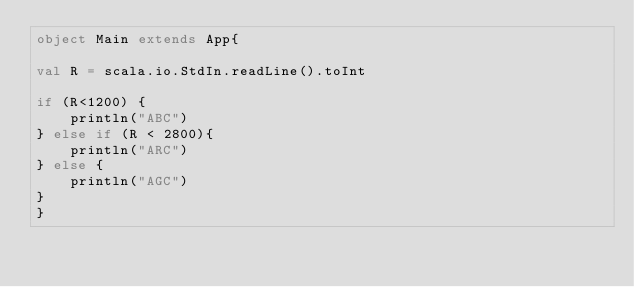<code> <loc_0><loc_0><loc_500><loc_500><_Scala_>object Main extends App{

val R = scala.io.StdIn.readLine().toInt

if (R<1200) {
    println("ABC")
} else if (R < 2800){
    println("ARC")
} else {
    println("AGC")
}
}</code> 